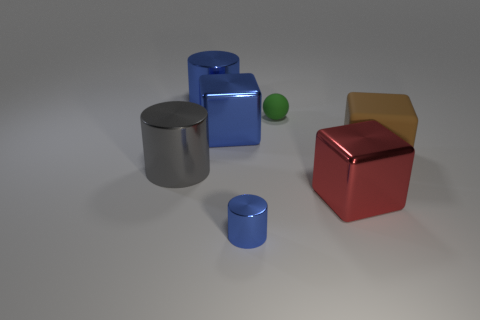Is the number of large brown matte cubes in front of the red cube less than the number of big purple metallic spheres?
Your answer should be very brief. No. There is a blue object in front of the big metallic object on the right side of the blue metal thing that is in front of the big red thing; what is its shape?
Ensure brevity in your answer.  Cylinder. Does the large matte cube have the same color as the small ball?
Ensure brevity in your answer.  No. Is the number of large blue cylinders greater than the number of big purple matte objects?
Your response must be concise. Yes. What number of other things are made of the same material as the small blue cylinder?
Ensure brevity in your answer.  4. What number of objects are either large gray matte objects or blue shiny cylinders left of the tiny blue cylinder?
Keep it short and to the point. 1. Is the number of large red things less than the number of small brown objects?
Give a very brief answer. No. There is a shiny cylinder in front of the metallic block that is right of the blue metal object that is in front of the large blue metallic cube; what is its color?
Provide a short and direct response. Blue. Are the big blue cylinder and the big brown cube made of the same material?
Offer a very short reply. No. There is a gray cylinder; how many metallic objects are in front of it?
Provide a short and direct response. 2. 